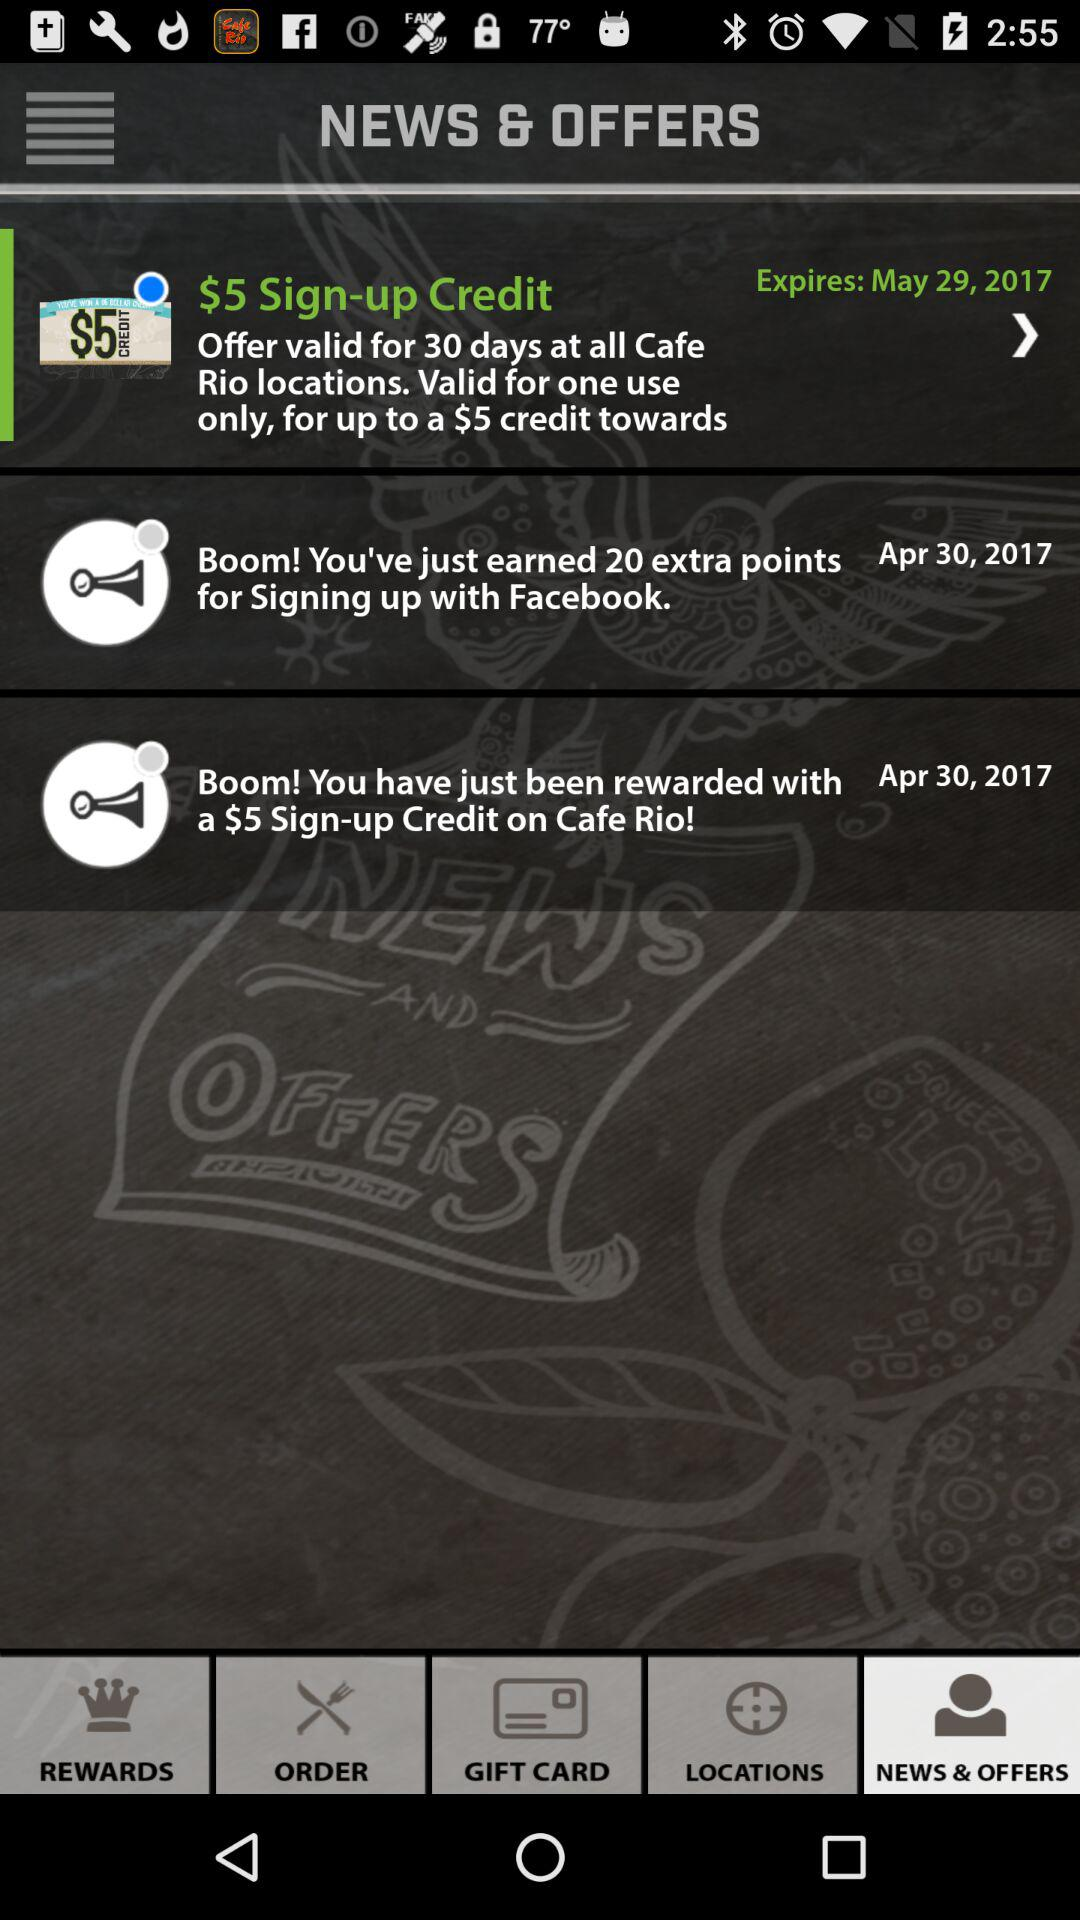What is the validity period? The validity period is 30 days. 